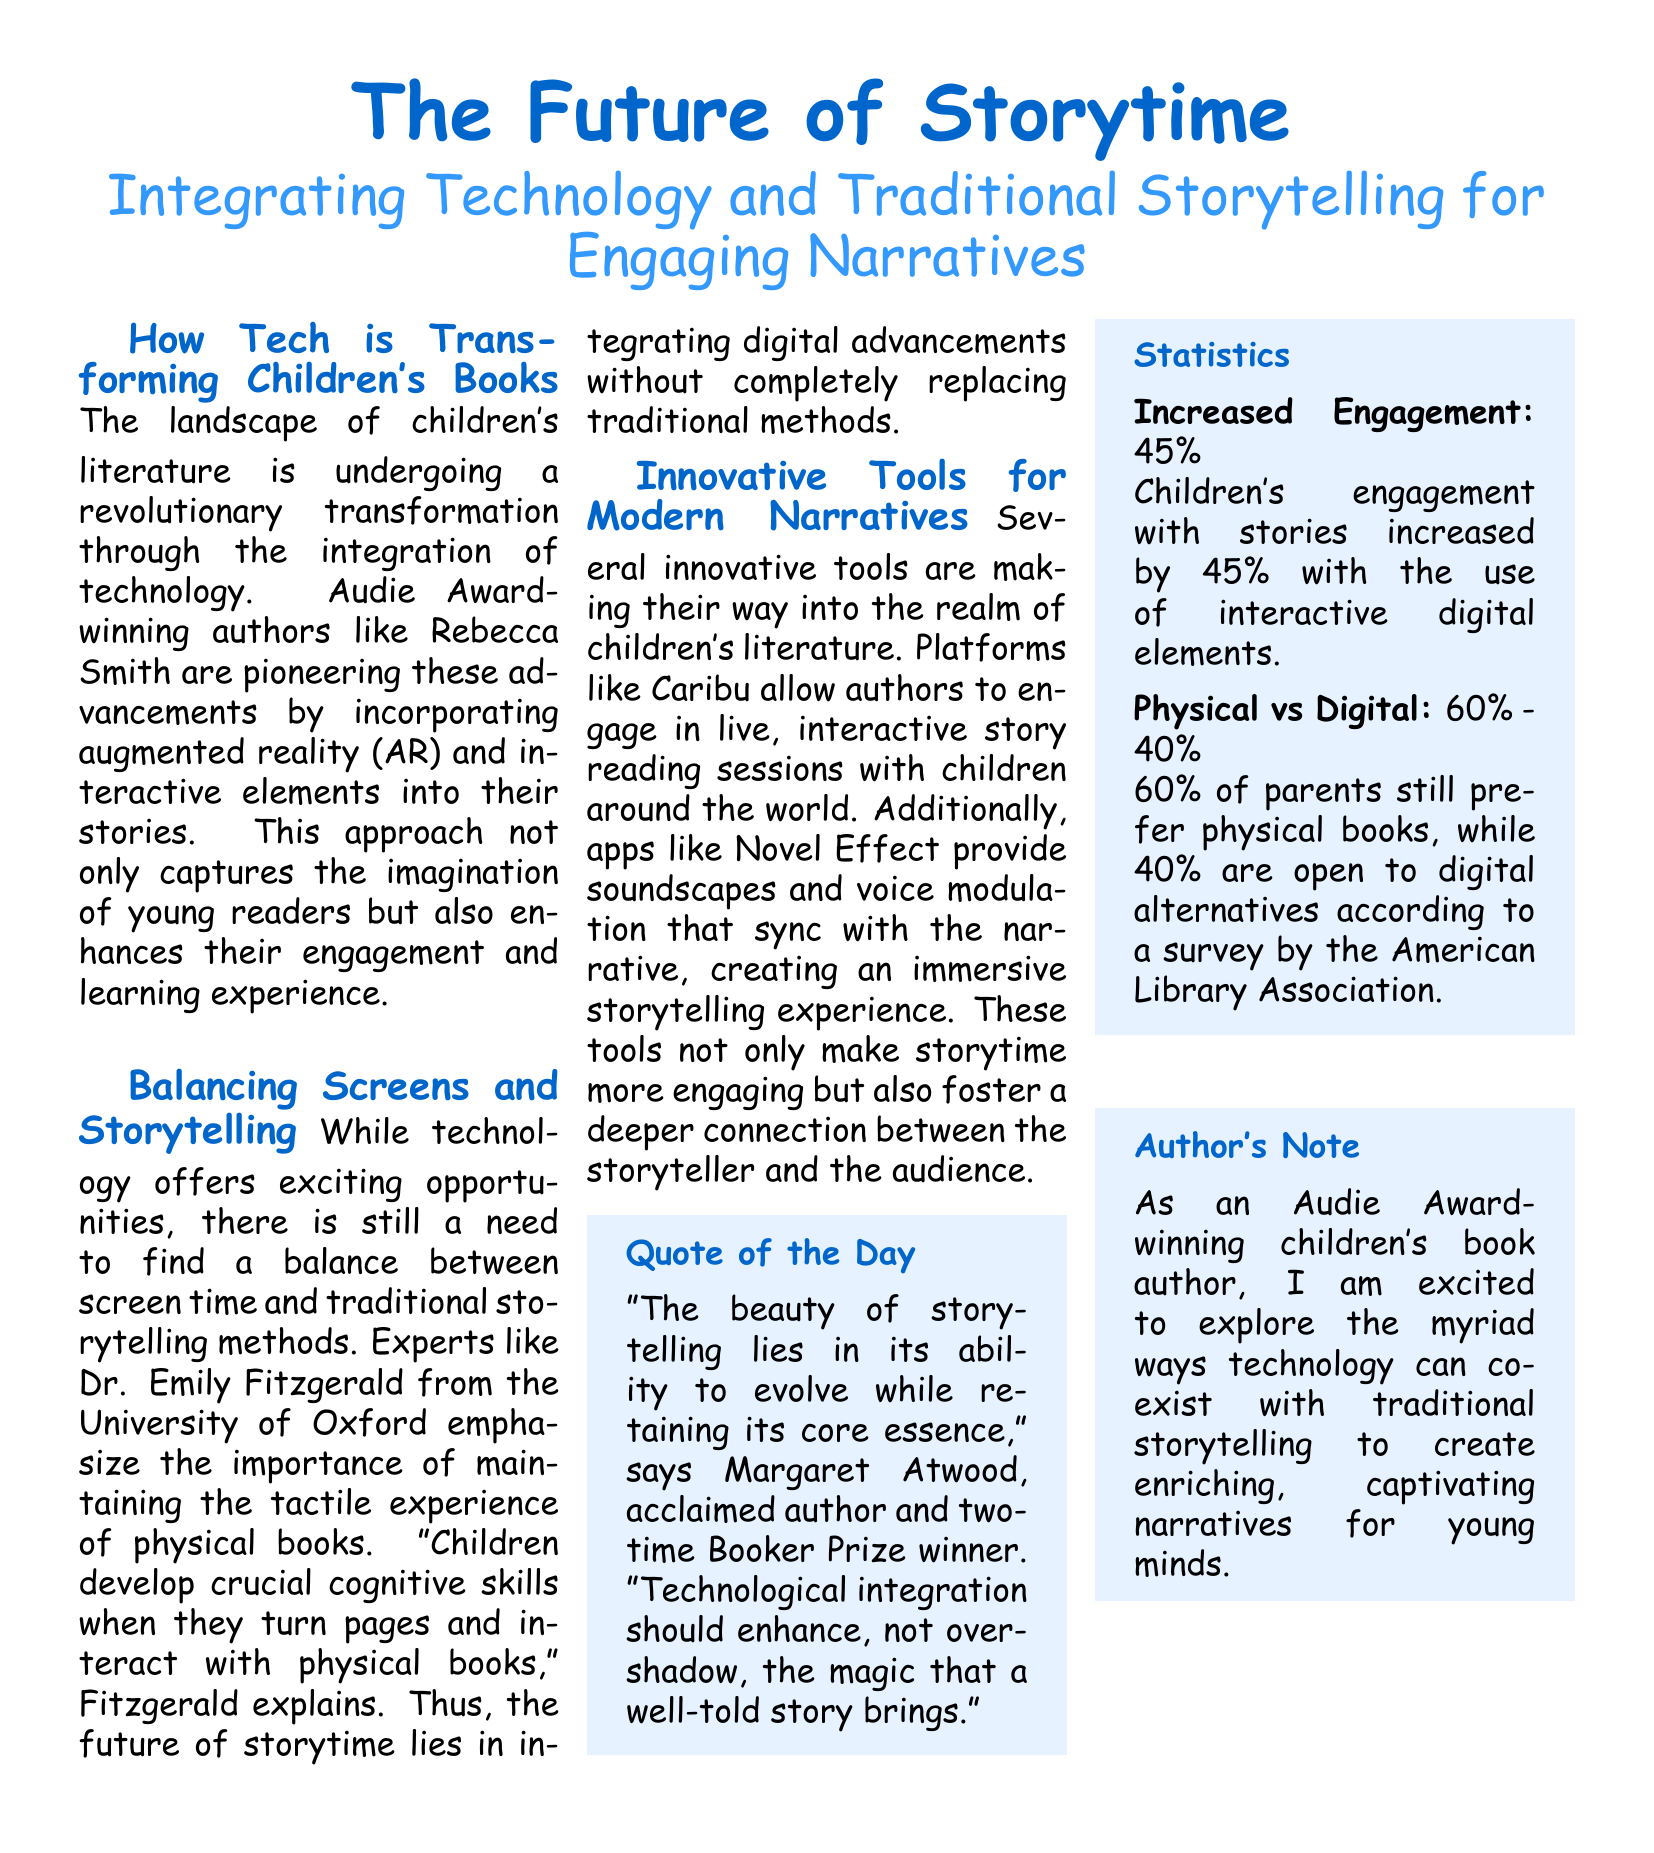What is the title of the article? The title appears prominently at the top of the document, highlighting the main topic of discussion.
Answer: The Future of Storytime Who is mentioned as a pioneering author? The document refers to a specific author known for integrating technology into children's literature.
Answer: Rebecca Smith What percentage of parents prefer physical books? The document presents statistics regarding parents' preferences between physical and digital books.
Answer: 60% What interactive platform is mentioned in the document? The text provides examples of tools used in modern storytelling for children's literature.
Answer: Caribu What was the increase in children's engagement with stories using digital elements? The document contains statistics showcasing the impact of interactive digital elements on engagement levels.
Answer: 45% Who provided the quote regarding storytelling and technological integration? The document cites an acclaimed author who shares insights on the evolution of storytelling.
Answer: Margaret Atwood What is the author’s note about? The author's note reflects their viewpoint and enthusiasm related to the subject discussed in the document.
Answer: Technology coexistence with traditional storytelling What is the percentage breakdown of physical to digital book preferences? The document outlines the survey results indicating the proportion of preferences among parents.
Answer: 60% - 40% 